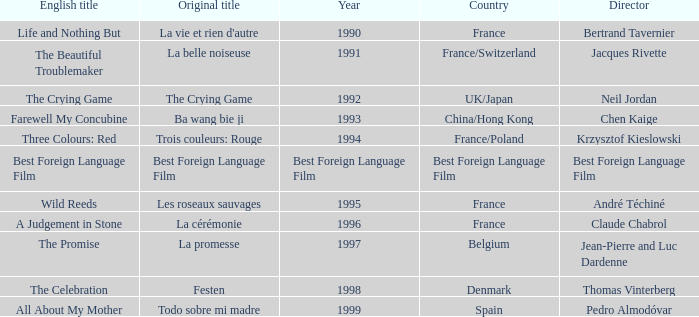Which Country has the Director Chen Kaige? China/Hong Kong. 